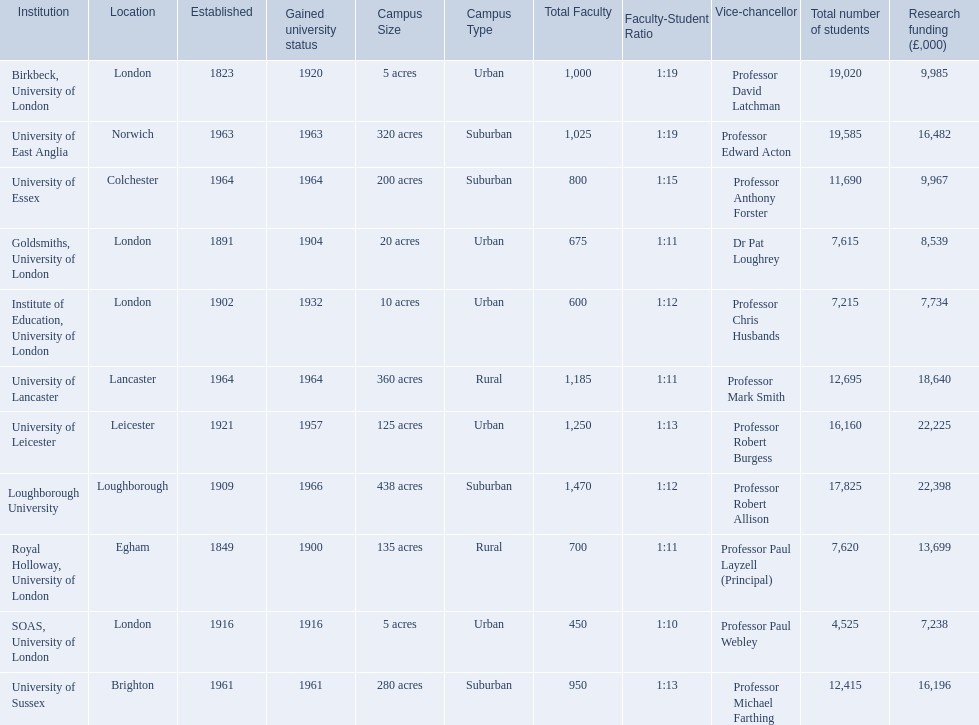What are the institutions in the 1994 group? Birkbeck, University of London, University of East Anglia, University of Essex, Goldsmiths, University of London, Institute of Education, University of London, University of Lancaster, University of Leicester, Loughborough University, Royal Holloway, University of London, SOAS, University of London, University of Sussex. Which of these was made a university most recently? Loughborough University. 